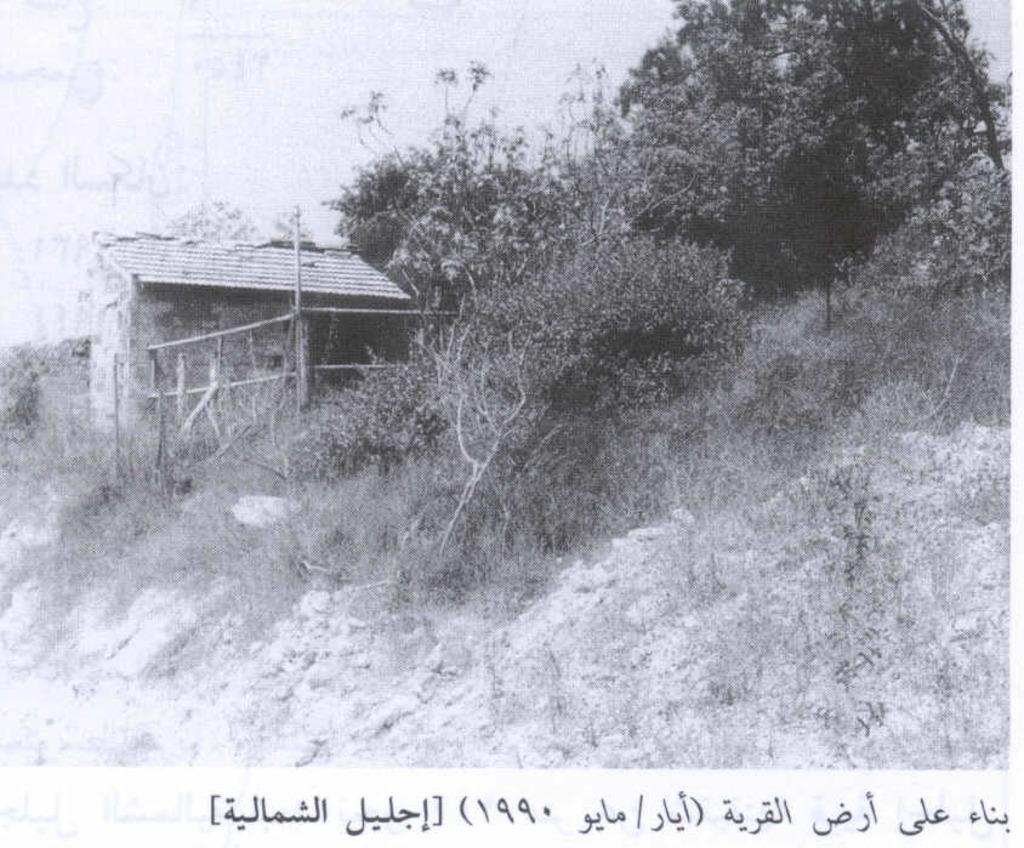What type of visual is the image? The image is a poster. What can be seen in the foreground of the poster? There are hurt (possibly referring to dirt or ground), trees, and plants in the foreground of the poster. What is visible in the background of the poster? The sky is visible in the poster. What type of guide is present in the image? There is no guide present in the image; it is a poster featuring hurt, trees, plants, and the sky. What is the condition of the hurt in the foreground of the image? The provided facts do not specify the condition of the hurt in the foreground of the image. 